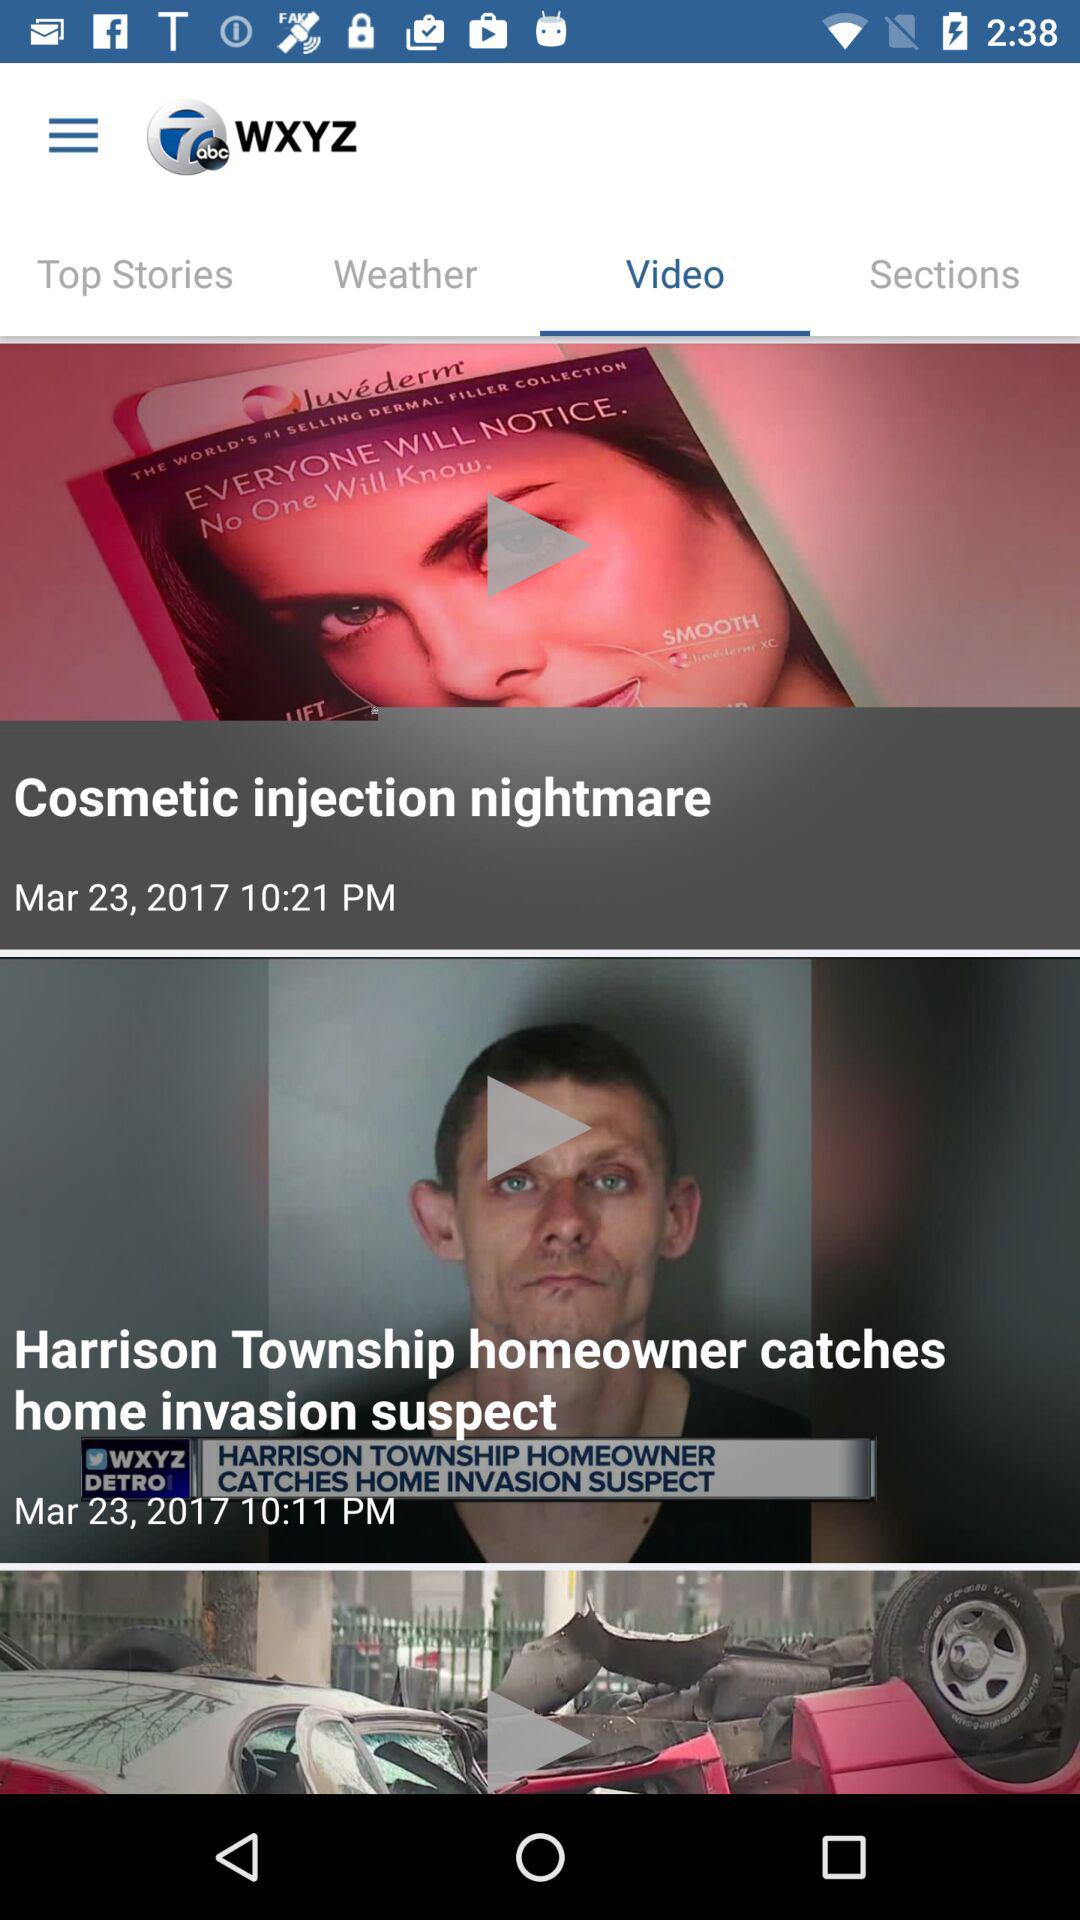When was the video "Harrison Township" published? The video was published on March 23, 2017 at 10:11 PM. 